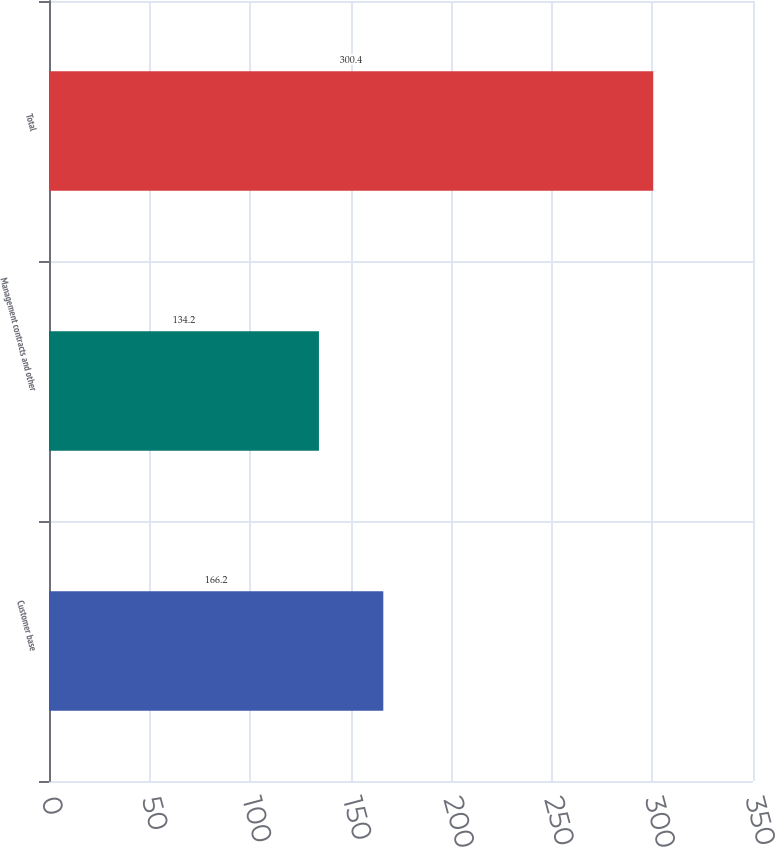Convert chart to OTSL. <chart><loc_0><loc_0><loc_500><loc_500><bar_chart><fcel>Customer base<fcel>Management contracts and other<fcel>Total<nl><fcel>166.2<fcel>134.2<fcel>300.4<nl></chart> 